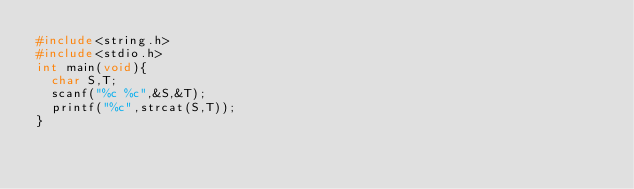<code> <loc_0><loc_0><loc_500><loc_500><_C_>#include<string.h>
#include<stdio.h>
int main(void){
  char S,T;
  scanf("%c %c",&S,&T);
  printf("%c",strcat(S,T));
}</code> 